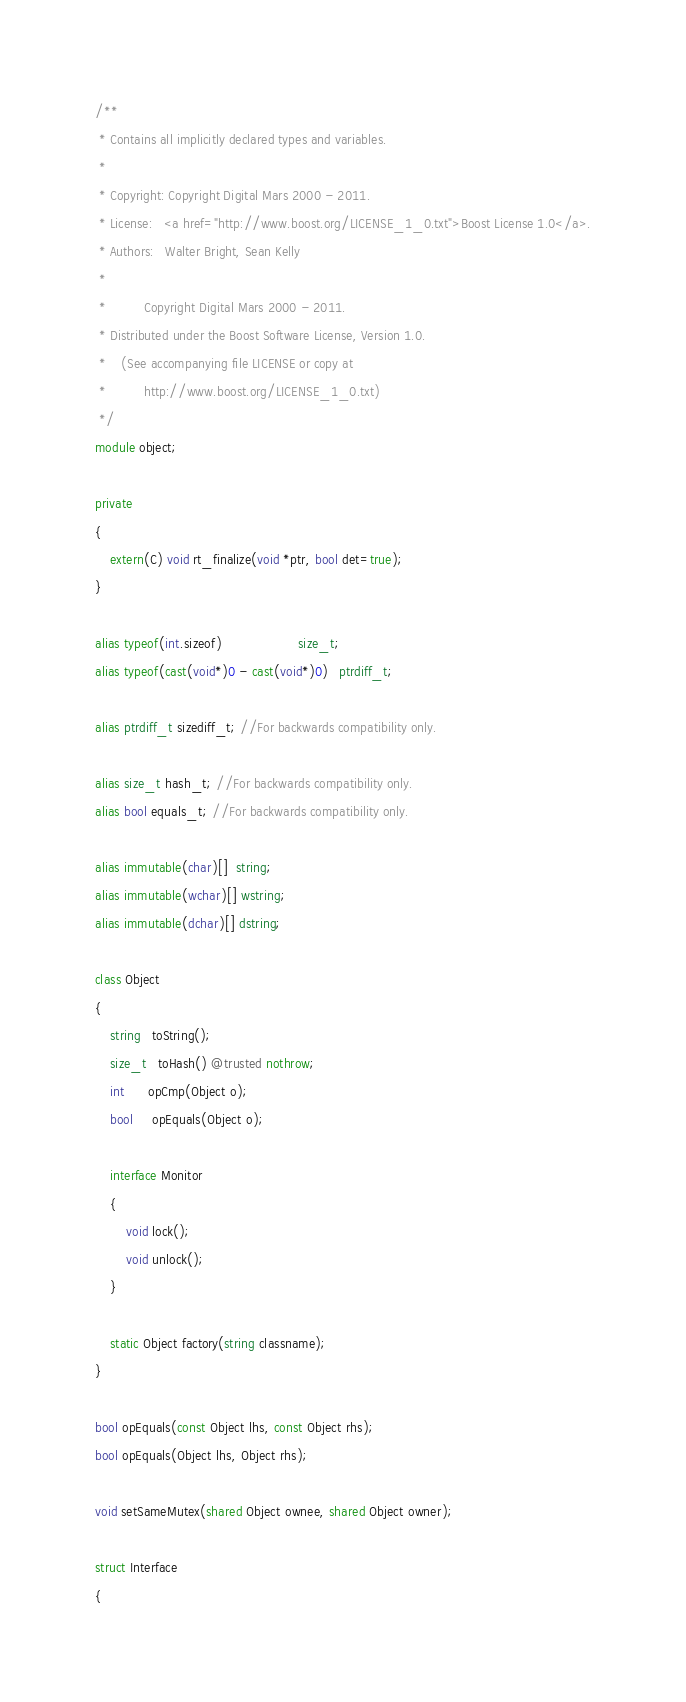Convert code to text. <code><loc_0><loc_0><loc_500><loc_500><_D_>/**
 * Contains all implicitly declared types and variables.
 *
 * Copyright: Copyright Digital Mars 2000 - 2011.
 * License:   <a href="http://www.boost.org/LICENSE_1_0.txt">Boost License 1.0</a>.
 * Authors:   Walter Bright, Sean Kelly
 *
 *          Copyright Digital Mars 2000 - 2011.
 * Distributed under the Boost Software License, Version 1.0.
 *    (See accompanying file LICENSE or copy at
 *          http://www.boost.org/LICENSE_1_0.txt)
 */
module object;

private
{
    extern(C) void rt_finalize(void *ptr, bool det=true);
}

alias typeof(int.sizeof)                    size_t;
alias typeof(cast(void*)0 - cast(void*)0)   ptrdiff_t;

alias ptrdiff_t sizediff_t; //For backwards compatibility only.

alias size_t hash_t; //For backwards compatibility only.
alias bool equals_t; //For backwards compatibility only.

alias immutable(char)[]  string;
alias immutable(wchar)[] wstring;
alias immutable(dchar)[] dstring;

class Object
{
    string   toString();
    size_t   toHash() @trusted nothrow;
    int      opCmp(Object o);
    bool     opEquals(Object o);

    interface Monitor
    {
        void lock();
        void unlock();
    }

    static Object factory(string classname);
}

bool opEquals(const Object lhs, const Object rhs);
bool opEquals(Object lhs, Object rhs);

void setSameMutex(shared Object ownee, shared Object owner);

struct Interface
{</code> 